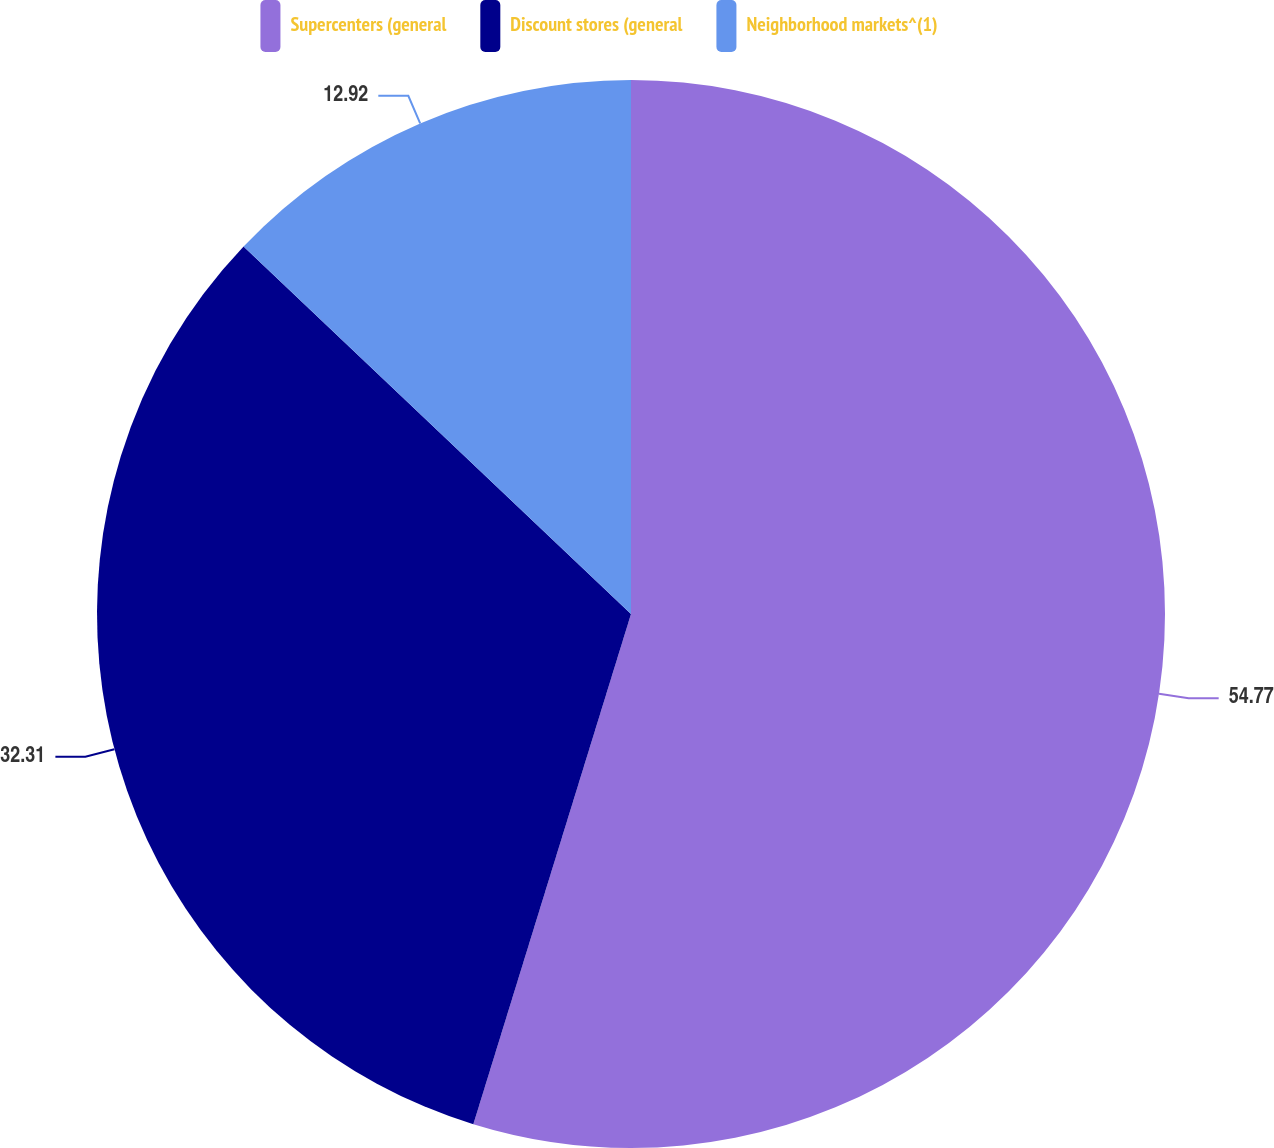Convert chart. <chart><loc_0><loc_0><loc_500><loc_500><pie_chart><fcel>Supercenters (general<fcel>Discount stores (general<fcel>Neighborhood markets^(1)<nl><fcel>54.77%<fcel>32.31%<fcel>12.92%<nl></chart> 